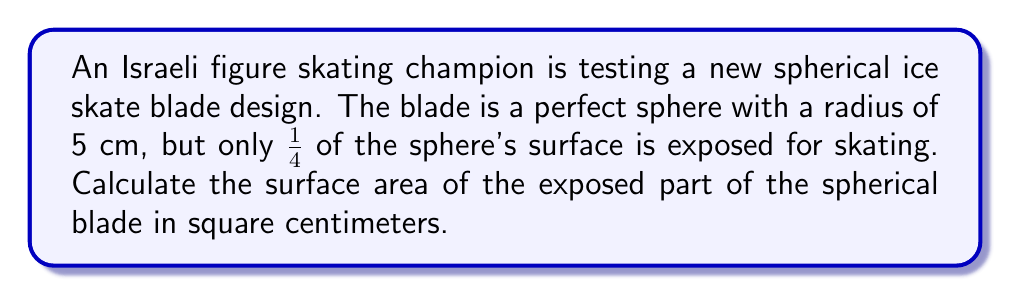Can you solve this math problem? To solve this problem, we'll follow these steps:

1) The formula for the surface area of a sphere is:
   $$A = 4\pi r^2$$
   where $r$ is the radius of the sphere.

2) We're given that the radius is 5 cm, so let's substitute this:
   $$A = 4\pi (5\text{ cm})^2 = 4\pi(25\text{ cm}^2) = 100\pi\text{ cm}^2$$

3) This is the surface area of the entire sphere. However, we're told that only 1/4 of the sphere's surface is exposed.

4) To find 1/4 of the total surface area, we multiply by 1/4:
   $$A_{\text{exposed}} = \frac{1}{4} \times 100\pi\text{ cm}^2 = 25\pi\text{ cm}^2$$

5) We can leave our answer in terms of $\pi$, or we can calculate an approximate value:
   $$25\pi\text{ cm}^2 \approx 78.54\text{ cm}^2$$

Therefore, the surface area of the exposed part of the spherical blade is $25\pi\text{ cm}^2$ or approximately 78.54 cm².
Answer: $25\pi\text{ cm}^2$ 